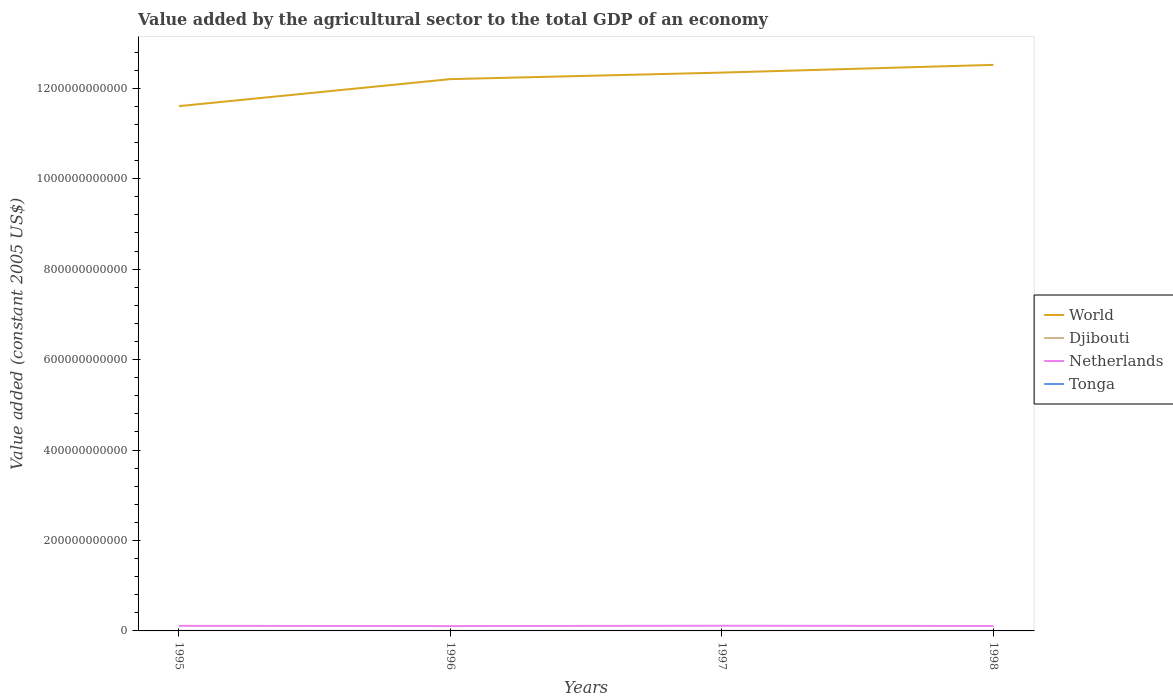Is the number of lines equal to the number of legend labels?
Your response must be concise. Yes. Across all years, what is the maximum value added by the agricultural sector in Netherlands?
Provide a succinct answer. 1.07e+1. What is the total value added by the agricultural sector in Netherlands in the graph?
Your answer should be very brief. -7.79e+08. What is the difference between the highest and the second highest value added by the agricultural sector in World?
Your answer should be very brief. 9.12e+1. What is the difference between the highest and the lowest value added by the agricultural sector in Tonga?
Keep it short and to the point. 2. Is the value added by the agricultural sector in Djibouti strictly greater than the value added by the agricultural sector in World over the years?
Make the answer very short. Yes. How many lines are there?
Offer a very short reply. 4. What is the difference between two consecutive major ticks on the Y-axis?
Keep it short and to the point. 2.00e+11. Are the values on the major ticks of Y-axis written in scientific E-notation?
Offer a terse response. No. Does the graph contain any zero values?
Offer a very short reply. No. Does the graph contain grids?
Make the answer very short. No. How are the legend labels stacked?
Your answer should be compact. Vertical. What is the title of the graph?
Keep it short and to the point. Value added by the agricultural sector to the total GDP of an economy. Does "Angola" appear as one of the legend labels in the graph?
Your response must be concise. No. What is the label or title of the X-axis?
Keep it short and to the point. Years. What is the label or title of the Y-axis?
Offer a terse response. Value added (constant 2005 US$). What is the Value added (constant 2005 US$) in World in 1995?
Offer a very short reply. 1.16e+12. What is the Value added (constant 2005 US$) of Djibouti in 1995?
Keep it short and to the point. 1.77e+07. What is the Value added (constant 2005 US$) in Netherlands in 1995?
Keep it short and to the point. 1.12e+1. What is the Value added (constant 2005 US$) of Tonga in 1995?
Your answer should be compact. 4.48e+07. What is the Value added (constant 2005 US$) in World in 1996?
Ensure brevity in your answer.  1.22e+12. What is the Value added (constant 2005 US$) of Djibouti in 1996?
Provide a short and direct response. 1.83e+07. What is the Value added (constant 2005 US$) of Netherlands in 1996?
Provide a short and direct response. 1.07e+1. What is the Value added (constant 2005 US$) of Tonga in 1996?
Give a very brief answer. 4.49e+07. What is the Value added (constant 2005 US$) of World in 1997?
Give a very brief answer. 1.23e+12. What is the Value added (constant 2005 US$) of Djibouti in 1997?
Offer a terse response. 1.83e+07. What is the Value added (constant 2005 US$) of Netherlands in 1997?
Provide a short and direct response. 1.15e+1. What is the Value added (constant 2005 US$) of Tonga in 1997?
Your answer should be compact. 4.85e+07. What is the Value added (constant 2005 US$) in World in 1998?
Provide a succinct answer. 1.25e+12. What is the Value added (constant 2005 US$) in Djibouti in 1998?
Offer a very short reply. 1.84e+07. What is the Value added (constant 2005 US$) in Netherlands in 1998?
Make the answer very short. 1.09e+1. What is the Value added (constant 2005 US$) in Tonga in 1998?
Your answer should be compact. 4.85e+07. Across all years, what is the maximum Value added (constant 2005 US$) in World?
Keep it short and to the point. 1.25e+12. Across all years, what is the maximum Value added (constant 2005 US$) of Djibouti?
Offer a terse response. 1.84e+07. Across all years, what is the maximum Value added (constant 2005 US$) in Netherlands?
Offer a very short reply. 1.15e+1. Across all years, what is the maximum Value added (constant 2005 US$) in Tonga?
Your answer should be very brief. 4.85e+07. Across all years, what is the minimum Value added (constant 2005 US$) in World?
Keep it short and to the point. 1.16e+12. Across all years, what is the minimum Value added (constant 2005 US$) in Djibouti?
Your response must be concise. 1.77e+07. Across all years, what is the minimum Value added (constant 2005 US$) in Netherlands?
Ensure brevity in your answer.  1.07e+1. Across all years, what is the minimum Value added (constant 2005 US$) in Tonga?
Your response must be concise. 4.48e+07. What is the total Value added (constant 2005 US$) of World in the graph?
Ensure brevity in your answer.  4.87e+12. What is the total Value added (constant 2005 US$) in Djibouti in the graph?
Provide a short and direct response. 7.28e+07. What is the total Value added (constant 2005 US$) in Netherlands in the graph?
Your answer should be compact. 4.44e+1. What is the total Value added (constant 2005 US$) in Tonga in the graph?
Make the answer very short. 1.87e+08. What is the difference between the Value added (constant 2005 US$) in World in 1995 and that in 1996?
Give a very brief answer. -5.97e+1. What is the difference between the Value added (constant 2005 US$) of Djibouti in 1995 and that in 1996?
Your response must be concise. -5.95e+05. What is the difference between the Value added (constant 2005 US$) in Netherlands in 1995 and that in 1996?
Provide a succinct answer. 5.35e+08. What is the difference between the Value added (constant 2005 US$) in Tonga in 1995 and that in 1996?
Offer a very short reply. -1.42e+05. What is the difference between the Value added (constant 2005 US$) in World in 1995 and that in 1997?
Ensure brevity in your answer.  -7.42e+1. What is the difference between the Value added (constant 2005 US$) in Djibouti in 1995 and that in 1997?
Offer a terse response. -5.31e+05. What is the difference between the Value added (constant 2005 US$) of Netherlands in 1995 and that in 1997?
Give a very brief answer. -2.44e+08. What is the difference between the Value added (constant 2005 US$) of Tonga in 1995 and that in 1997?
Offer a very short reply. -3.75e+06. What is the difference between the Value added (constant 2005 US$) in World in 1995 and that in 1998?
Your answer should be very brief. -9.12e+1. What is the difference between the Value added (constant 2005 US$) in Djibouti in 1995 and that in 1998?
Offer a very short reply. -6.72e+05. What is the difference between the Value added (constant 2005 US$) in Netherlands in 1995 and that in 1998?
Offer a very short reply. 3.15e+08. What is the difference between the Value added (constant 2005 US$) in Tonga in 1995 and that in 1998?
Your answer should be compact. -3.76e+06. What is the difference between the Value added (constant 2005 US$) of World in 1996 and that in 1997?
Give a very brief answer. -1.45e+1. What is the difference between the Value added (constant 2005 US$) of Djibouti in 1996 and that in 1997?
Give a very brief answer. 6.39e+04. What is the difference between the Value added (constant 2005 US$) of Netherlands in 1996 and that in 1997?
Your response must be concise. -7.79e+08. What is the difference between the Value added (constant 2005 US$) of Tonga in 1996 and that in 1997?
Offer a very short reply. -3.61e+06. What is the difference between the Value added (constant 2005 US$) of World in 1996 and that in 1998?
Ensure brevity in your answer.  -3.15e+1. What is the difference between the Value added (constant 2005 US$) in Djibouti in 1996 and that in 1998?
Your answer should be very brief. -7.70e+04. What is the difference between the Value added (constant 2005 US$) of Netherlands in 1996 and that in 1998?
Provide a short and direct response. -2.20e+08. What is the difference between the Value added (constant 2005 US$) of Tonga in 1996 and that in 1998?
Ensure brevity in your answer.  -3.62e+06. What is the difference between the Value added (constant 2005 US$) of World in 1997 and that in 1998?
Make the answer very short. -1.71e+1. What is the difference between the Value added (constant 2005 US$) in Djibouti in 1997 and that in 1998?
Ensure brevity in your answer.  -1.41e+05. What is the difference between the Value added (constant 2005 US$) of Netherlands in 1997 and that in 1998?
Your response must be concise. 5.59e+08. What is the difference between the Value added (constant 2005 US$) in Tonga in 1997 and that in 1998?
Your answer should be very brief. -9550.13. What is the difference between the Value added (constant 2005 US$) of World in 1995 and the Value added (constant 2005 US$) of Djibouti in 1996?
Ensure brevity in your answer.  1.16e+12. What is the difference between the Value added (constant 2005 US$) in World in 1995 and the Value added (constant 2005 US$) in Netherlands in 1996?
Provide a succinct answer. 1.15e+12. What is the difference between the Value added (constant 2005 US$) of World in 1995 and the Value added (constant 2005 US$) of Tonga in 1996?
Give a very brief answer. 1.16e+12. What is the difference between the Value added (constant 2005 US$) of Djibouti in 1995 and the Value added (constant 2005 US$) of Netherlands in 1996?
Ensure brevity in your answer.  -1.07e+1. What is the difference between the Value added (constant 2005 US$) in Djibouti in 1995 and the Value added (constant 2005 US$) in Tonga in 1996?
Provide a succinct answer. -2.72e+07. What is the difference between the Value added (constant 2005 US$) in Netherlands in 1995 and the Value added (constant 2005 US$) in Tonga in 1996?
Your answer should be very brief. 1.12e+1. What is the difference between the Value added (constant 2005 US$) in World in 1995 and the Value added (constant 2005 US$) in Djibouti in 1997?
Your answer should be very brief. 1.16e+12. What is the difference between the Value added (constant 2005 US$) in World in 1995 and the Value added (constant 2005 US$) in Netherlands in 1997?
Your answer should be very brief. 1.15e+12. What is the difference between the Value added (constant 2005 US$) in World in 1995 and the Value added (constant 2005 US$) in Tonga in 1997?
Your answer should be compact. 1.16e+12. What is the difference between the Value added (constant 2005 US$) of Djibouti in 1995 and the Value added (constant 2005 US$) of Netherlands in 1997?
Your answer should be very brief. -1.15e+1. What is the difference between the Value added (constant 2005 US$) in Djibouti in 1995 and the Value added (constant 2005 US$) in Tonga in 1997?
Keep it short and to the point. -3.08e+07. What is the difference between the Value added (constant 2005 US$) of Netherlands in 1995 and the Value added (constant 2005 US$) of Tonga in 1997?
Ensure brevity in your answer.  1.12e+1. What is the difference between the Value added (constant 2005 US$) of World in 1995 and the Value added (constant 2005 US$) of Djibouti in 1998?
Your answer should be very brief. 1.16e+12. What is the difference between the Value added (constant 2005 US$) of World in 1995 and the Value added (constant 2005 US$) of Netherlands in 1998?
Give a very brief answer. 1.15e+12. What is the difference between the Value added (constant 2005 US$) in World in 1995 and the Value added (constant 2005 US$) in Tonga in 1998?
Make the answer very short. 1.16e+12. What is the difference between the Value added (constant 2005 US$) of Djibouti in 1995 and the Value added (constant 2005 US$) of Netherlands in 1998?
Offer a terse response. -1.09e+1. What is the difference between the Value added (constant 2005 US$) of Djibouti in 1995 and the Value added (constant 2005 US$) of Tonga in 1998?
Your response must be concise. -3.08e+07. What is the difference between the Value added (constant 2005 US$) of Netherlands in 1995 and the Value added (constant 2005 US$) of Tonga in 1998?
Your answer should be compact. 1.12e+1. What is the difference between the Value added (constant 2005 US$) in World in 1996 and the Value added (constant 2005 US$) in Djibouti in 1997?
Your answer should be compact. 1.22e+12. What is the difference between the Value added (constant 2005 US$) of World in 1996 and the Value added (constant 2005 US$) of Netherlands in 1997?
Ensure brevity in your answer.  1.21e+12. What is the difference between the Value added (constant 2005 US$) in World in 1996 and the Value added (constant 2005 US$) in Tonga in 1997?
Offer a very short reply. 1.22e+12. What is the difference between the Value added (constant 2005 US$) in Djibouti in 1996 and the Value added (constant 2005 US$) in Netherlands in 1997?
Your response must be concise. -1.15e+1. What is the difference between the Value added (constant 2005 US$) in Djibouti in 1996 and the Value added (constant 2005 US$) in Tonga in 1997?
Provide a succinct answer. -3.02e+07. What is the difference between the Value added (constant 2005 US$) in Netherlands in 1996 and the Value added (constant 2005 US$) in Tonga in 1997?
Your answer should be compact. 1.07e+1. What is the difference between the Value added (constant 2005 US$) of World in 1996 and the Value added (constant 2005 US$) of Djibouti in 1998?
Make the answer very short. 1.22e+12. What is the difference between the Value added (constant 2005 US$) of World in 1996 and the Value added (constant 2005 US$) of Netherlands in 1998?
Your answer should be compact. 1.21e+12. What is the difference between the Value added (constant 2005 US$) of World in 1996 and the Value added (constant 2005 US$) of Tonga in 1998?
Make the answer very short. 1.22e+12. What is the difference between the Value added (constant 2005 US$) of Djibouti in 1996 and the Value added (constant 2005 US$) of Netherlands in 1998?
Make the answer very short. -1.09e+1. What is the difference between the Value added (constant 2005 US$) in Djibouti in 1996 and the Value added (constant 2005 US$) in Tonga in 1998?
Your answer should be very brief. -3.02e+07. What is the difference between the Value added (constant 2005 US$) in Netherlands in 1996 and the Value added (constant 2005 US$) in Tonga in 1998?
Provide a short and direct response. 1.07e+1. What is the difference between the Value added (constant 2005 US$) in World in 1997 and the Value added (constant 2005 US$) in Djibouti in 1998?
Give a very brief answer. 1.23e+12. What is the difference between the Value added (constant 2005 US$) of World in 1997 and the Value added (constant 2005 US$) of Netherlands in 1998?
Offer a terse response. 1.22e+12. What is the difference between the Value added (constant 2005 US$) of World in 1997 and the Value added (constant 2005 US$) of Tonga in 1998?
Your answer should be compact. 1.23e+12. What is the difference between the Value added (constant 2005 US$) in Djibouti in 1997 and the Value added (constant 2005 US$) in Netherlands in 1998?
Offer a very short reply. -1.09e+1. What is the difference between the Value added (constant 2005 US$) of Djibouti in 1997 and the Value added (constant 2005 US$) of Tonga in 1998?
Make the answer very short. -3.03e+07. What is the difference between the Value added (constant 2005 US$) of Netherlands in 1997 and the Value added (constant 2005 US$) of Tonga in 1998?
Your response must be concise. 1.14e+1. What is the average Value added (constant 2005 US$) of World per year?
Your answer should be compact. 1.22e+12. What is the average Value added (constant 2005 US$) of Djibouti per year?
Give a very brief answer. 1.82e+07. What is the average Value added (constant 2005 US$) in Netherlands per year?
Offer a terse response. 1.11e+1. What is the average Value added (constant 2005 US$) of Tonga per year?
Offer a very short reply. 4.67e+07. In the year 1995, what is the difference between the Value added (constant 2005 US$) in World and Value added (constant 2005 US$) in Djibouti?
Your response must be concise. 1.16e+12. In the year 1995, what is the difference between the Value added (constant 2005 US$) in World and Value added (constant 2005 US$) in Netherlands?
Offer a very short reply. 1.15e+12. In the year 1995, what is the difference between the Value added (constant 2005 US$) in World and Value added (constant 2005 US$) in Tonga?
Make the answer very short. 1.16e+12. In the year 1995, what is the difference between the Value added (constant 2005 US$) in Djibouti and Value added (constant 2005 US$) in Netherlands?
Your answer should be very brief. -1.12e+1. In the year 1995, what is the difference between the Value added (constant 2005 US$) of Djibouti and Value added (constant 2005 US$) of Tonga?
Keep it short and to the point. -2.70e+07. In the year 1995, what is the difference between the Value added (constant 2005 US$) of Netherlands and Value added (constant 2005 US$) of Tonga?
Provide a short and direct response. 1.12e+1. In the year 1996, what is the difference between the Value added (constant 2005 US$) of World and Value added (constant 2005 US$) of Djibouti?
Give a very brief answer. 1.22e+12. In the year 1996, what is the difference between the Value added (constant 2005 US$) of World and Value added (constant 2005 US$) of Netherlands?
Keep it short and to the point. 1.21e+12. In the year 1996, what is the difference between the Value added (constant 2005 US$) of World and Value added (constant 2005 US$) of Tonga?
Give a very brief answer. 1.22e+12. In the year 1996, what is the difference between the Value added (constant 2005 US$) of Djibouti and Value added (constant 2005 US$) of Netherlands?
Your answer should be compact. -1.07e+1. In the year 1996, what is the difference between the Value added (constant 2005 US$) of Djibouti and Value added (constant 2005 US$) of Tonga?
Offer a terse response. -2.66e+07. In the year 1996, what is the difference between the Value added (constant 2005 US$) of Netherlands and Value added (constant 2005 US$) of Tonga?
Provide a short and direct response. 1.07e+1. In the year 1997, what is the difference between the Value added (constant 2005 US$) of World and Value added (constant 2005 US$) of Djibouti?
Give a very brief answer. 1.23e+12. In the year 1997, what is the difference between the Value added (constant 2005 US$) of World and Value added (constant 2005 US$) of Netherlands?
Provide a succinct answer. 1.22e+12. In the year 1997, what is the difference between the Value added (constant 2005 US$) in World and Value added (constant 2005 US$) in Tonga?
Offer a terse response. 1.23e+12. In the year 1997, what is the difference between the Value added (constant 2005 US$) of Djibouti and Value added (constant 2005 US$) of Netherlands?
Give a very brief answer. -1.15e+1. In the year 1997, what is the difference between the Value added (constant 2005 US$) in Djibouti and Value added (constant 2005 US$) in Tonga?
Your response must be concise. -3.02e+07. In the year 1997, what is the difference between the Value added (constant 2005 US$) of Netherlands and Value added (constant 2005 US$) of Tonga?
Make the answer very short. 1.14e+1. In the year 1998, what is the difference between the Value added (constant 2005 US$) of World and Value added (constant 2005 US$) of Djibouti?
Provide a short and direct response. 1.25e+12. In the year 1998, what is the difference between the Value added (constant 2005 US$) of World and Value added (constant 2005 US$) of Netherlands?
Keep it short and to the point. 1.24e+12. In the year 1998, what is the difference between the Value added (constant 2005 US$) of World and Value added (constant 2005 US$) of Tonga?
Keep it short and to the point. 1.25e+12. In the year 1998, what is the difference between the Value added (constant 2005 US$) of Djibouti and Value added (constant 2005 US$) of Netherlands?
Offer a very short reply. -1.09e+1. In the year 1998, what is the difference between the Value added (constant 2005 US$) in Djibouti and Value added (constant 2005 US$) in Tonga?
Offer a terse response. -3.01e+07. In the year 1998, what is the difference between the Value added (constant 2005 US$) of Netherlands and Value added (constant 2005 US$) of Tonga?
Ensure brevity in your answer.  1.09e+1. What is the ratio of the Value added (constant 2005 US$) of World in 1995 to that in 1996?
Ensure brevity in your answer.  0.95. What is the ratio of the Value added (constant 2005 US$) of Djibouti in 1995 to that in 1996?
Keep it short and to the point. 0.97. What is the ratio of the Value added (constant 2005 US$) in Tonga in 1995 to that in 1996?
Offer a terse response. 1. What is the ratio of the Value added (constant 2005 US$) of World in 1995 to that in 1997?
Provide a short and direct response. 0.94. What is the ratio of the Value added (constant 2005 US$) of Djibouti in 1995 to that in 1997?
Provide a short and direct response. 0.97. What is the ratio of the Value added (constant 2005 US$) of Netherlands in 1995 to that in 1997?
Make the answer very short. 0.98. What is the ratio of the Value added (constant 2005 US$) in Tonga in 1995 to that in 1997?
Ensure brevity in your answer.  0.92. What is the ratio of the Value added (constant 2005 US$) of World in 1995 to that in 1998?
Offer a very short reply. 0.93. What is the ratio of the Value added (constant 2005 US$) of Djibouti in 1995 to that in 1998?
Make the answer very short. 0.96. What is the ratio of the Value added (constant 2005 US$) of Netherlands in 1995 to that in 1998?
Keep it short and to the point. 1.03. What is the ratio of the Value added (constant 2005 US$) in Tonga in 1995 to that in 1998?
Keep it short and to the point. 0.92. What is the ratio of the Value added (constant 2005 US$) in World in 1996 to that in 1997?
Offer a terse response. 0.99. What is the ratio of the Value added (constant 2005 US$) in Netherlands in 1996 to that in 1997?
Give a very brief answer. 0.93. What is the ratio of the Value added (constant 2005 US$) in Tonga in 1996 to that in 1997?
Make the answer very short. 0.93. What is the ratio of the Value added (constant 2005 US$) in World in 1996 to that in 1998?
Offer a terse response. 0.97. What is the ratio of the Value added (constant 2005 US$) of Netherlands in 1996 to that in 1998?
Provide a succinct answer. 0.98. What is the ratio of the Value added (constant 2005 US$) of Tonga in 1996 to that in 1998?
Keep it short and to the point. 0.93. What is the ratio of the Value added (constant 2005 US$) in World in 1997 to that in 1998?
Make the answer very short. 0.99. What is the ratio of the Value added (constant 2005 US$) in Netherlands in 1997 to that in 1998?
Your answer should be compact. 1.05. What is the ratio of the Value added (constant 2005 US$) of Tonga in 1997 to that in 1998?
Give a very brief answer. 1. What is the difference between the highest and the second highest Value added (constant 2005 US$) in World?
Your response must be concise. 1.71e+1. What is the difference between the highest and the second highest Value added (constant 2005 US$) of Djibouti?
Your answer should be compact. 7.70e+04. What is the difference between the highest and the second highest Value added (constant 2005 US$) of Netherlands?
Give a very brief answer. 2.44e+08. What is the difference between the highest and the second highest Value added (constant 2005 US$) of Tonga?
Your answer should be compact. 9550.13. What is the difference between the highest and the lowest Value added (constant 2005 US$) in World?
Your answer should be very brief. 9.12e+1. What is the difference between the highest and the lowest Value added (constant 2005 US$) in Djibouti?
Ensure brevity in your answer.  6.72e+05. What is the difference between the highest and the lowest Value added (constant 2005 US$) in Netherlands?
Provide a short and direct response. 7.79e+08. What is the difference between the highest and the lowest Value added (constant 2005 US$) in Tonga?
Make the answer very short. 3.76e+06. 